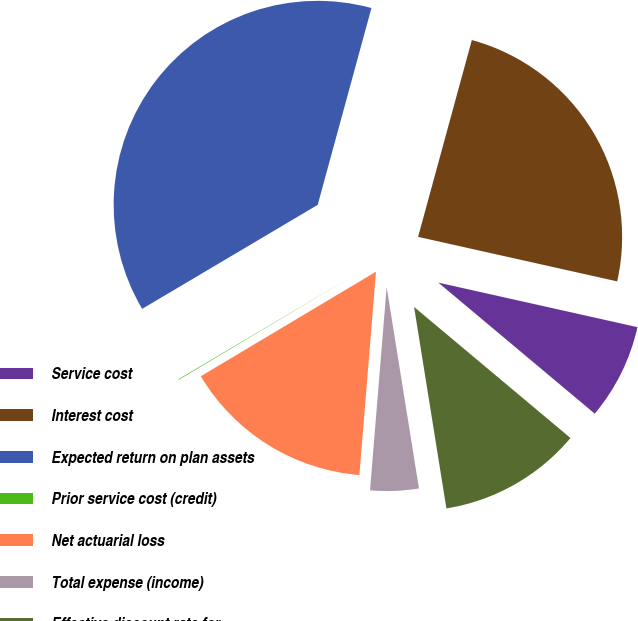Convert chart. <chart><loc_0><loc_0><loc_500><loc_500><pie_chart><fcel>Service cost<fcel>Interest cost<fcel>Expected return on plan assets<fcel>Prior service cost (credit)<fcel>Net actuarial loss<fcel>Total expense (income)<fcel>Effective discount rate for<nl><fcel>7.6%<fcel>24.26%<fcel>37.76%<fcel>0.05%<fcel>15.14%<fcel>3.83%<fcel>11.37%<nl></chart> 